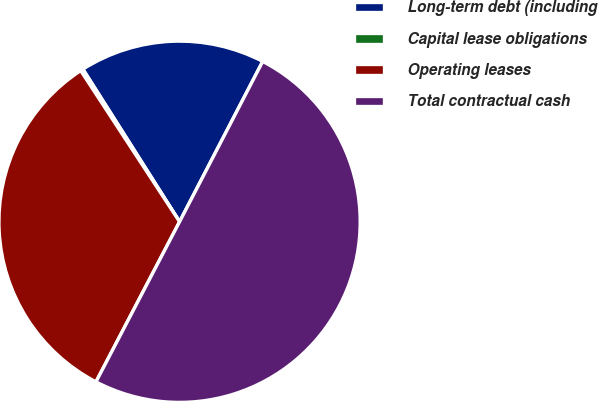Convert chart to OTSL. <chart><loc_0><loc_0><loc_500><loc_500><pie_chart><fcel>Long-term debt (including<fcel>Capital lease obligations<fcel>Operating leases<fcel>Total contractual cash<nl><fcel>16.6%<fcel>0.23%<fcel>33.12%<fcel>50.04%<nl></chart> 